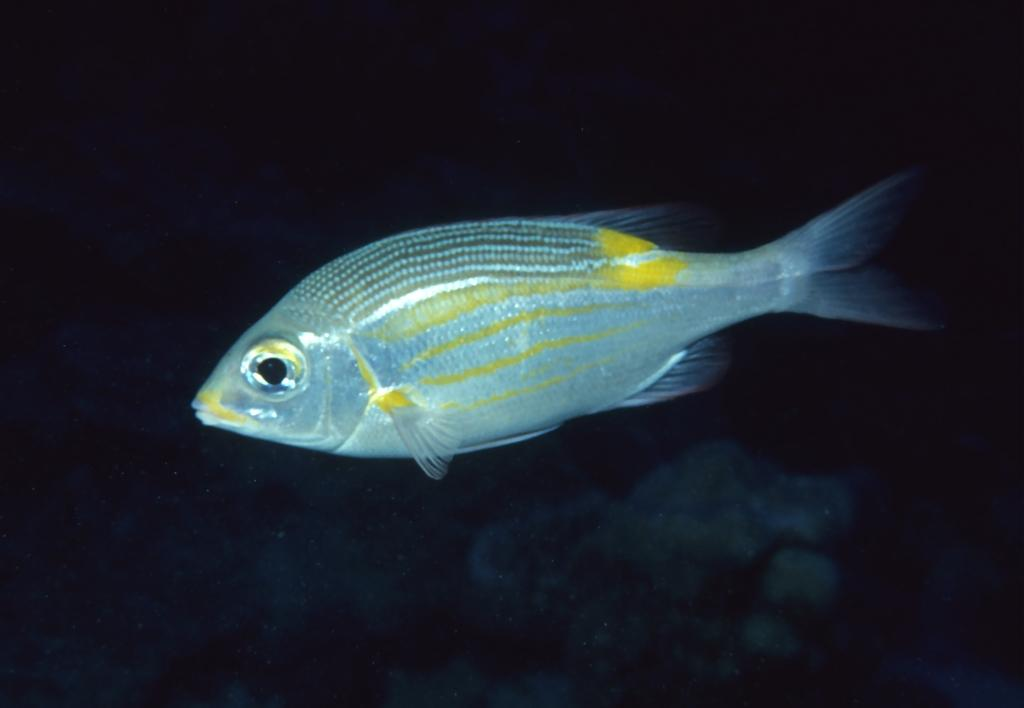What type of animal is in the image? There is a fish in the image. What colors can be seen on the fish? The fish has yellow and silver colors. Where was the image likely taken? The image appears to be taken in the water. How many mint leaves are floating next to the fish in the image? There are no mint leaves visible in the image; it only features a fish in the water. 